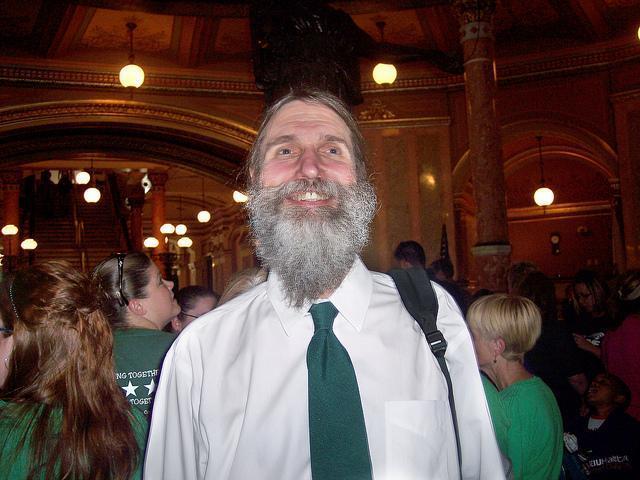How many people are there?
Give a very brief answer. 7. 